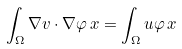<formula> <loc_0><loc_0><loc_500><loc_500>\int _ { \Omega } \nabla v \cdot \nabla \varphi \, x = \int _ { \Omega } u \varphi \, x</formula> 